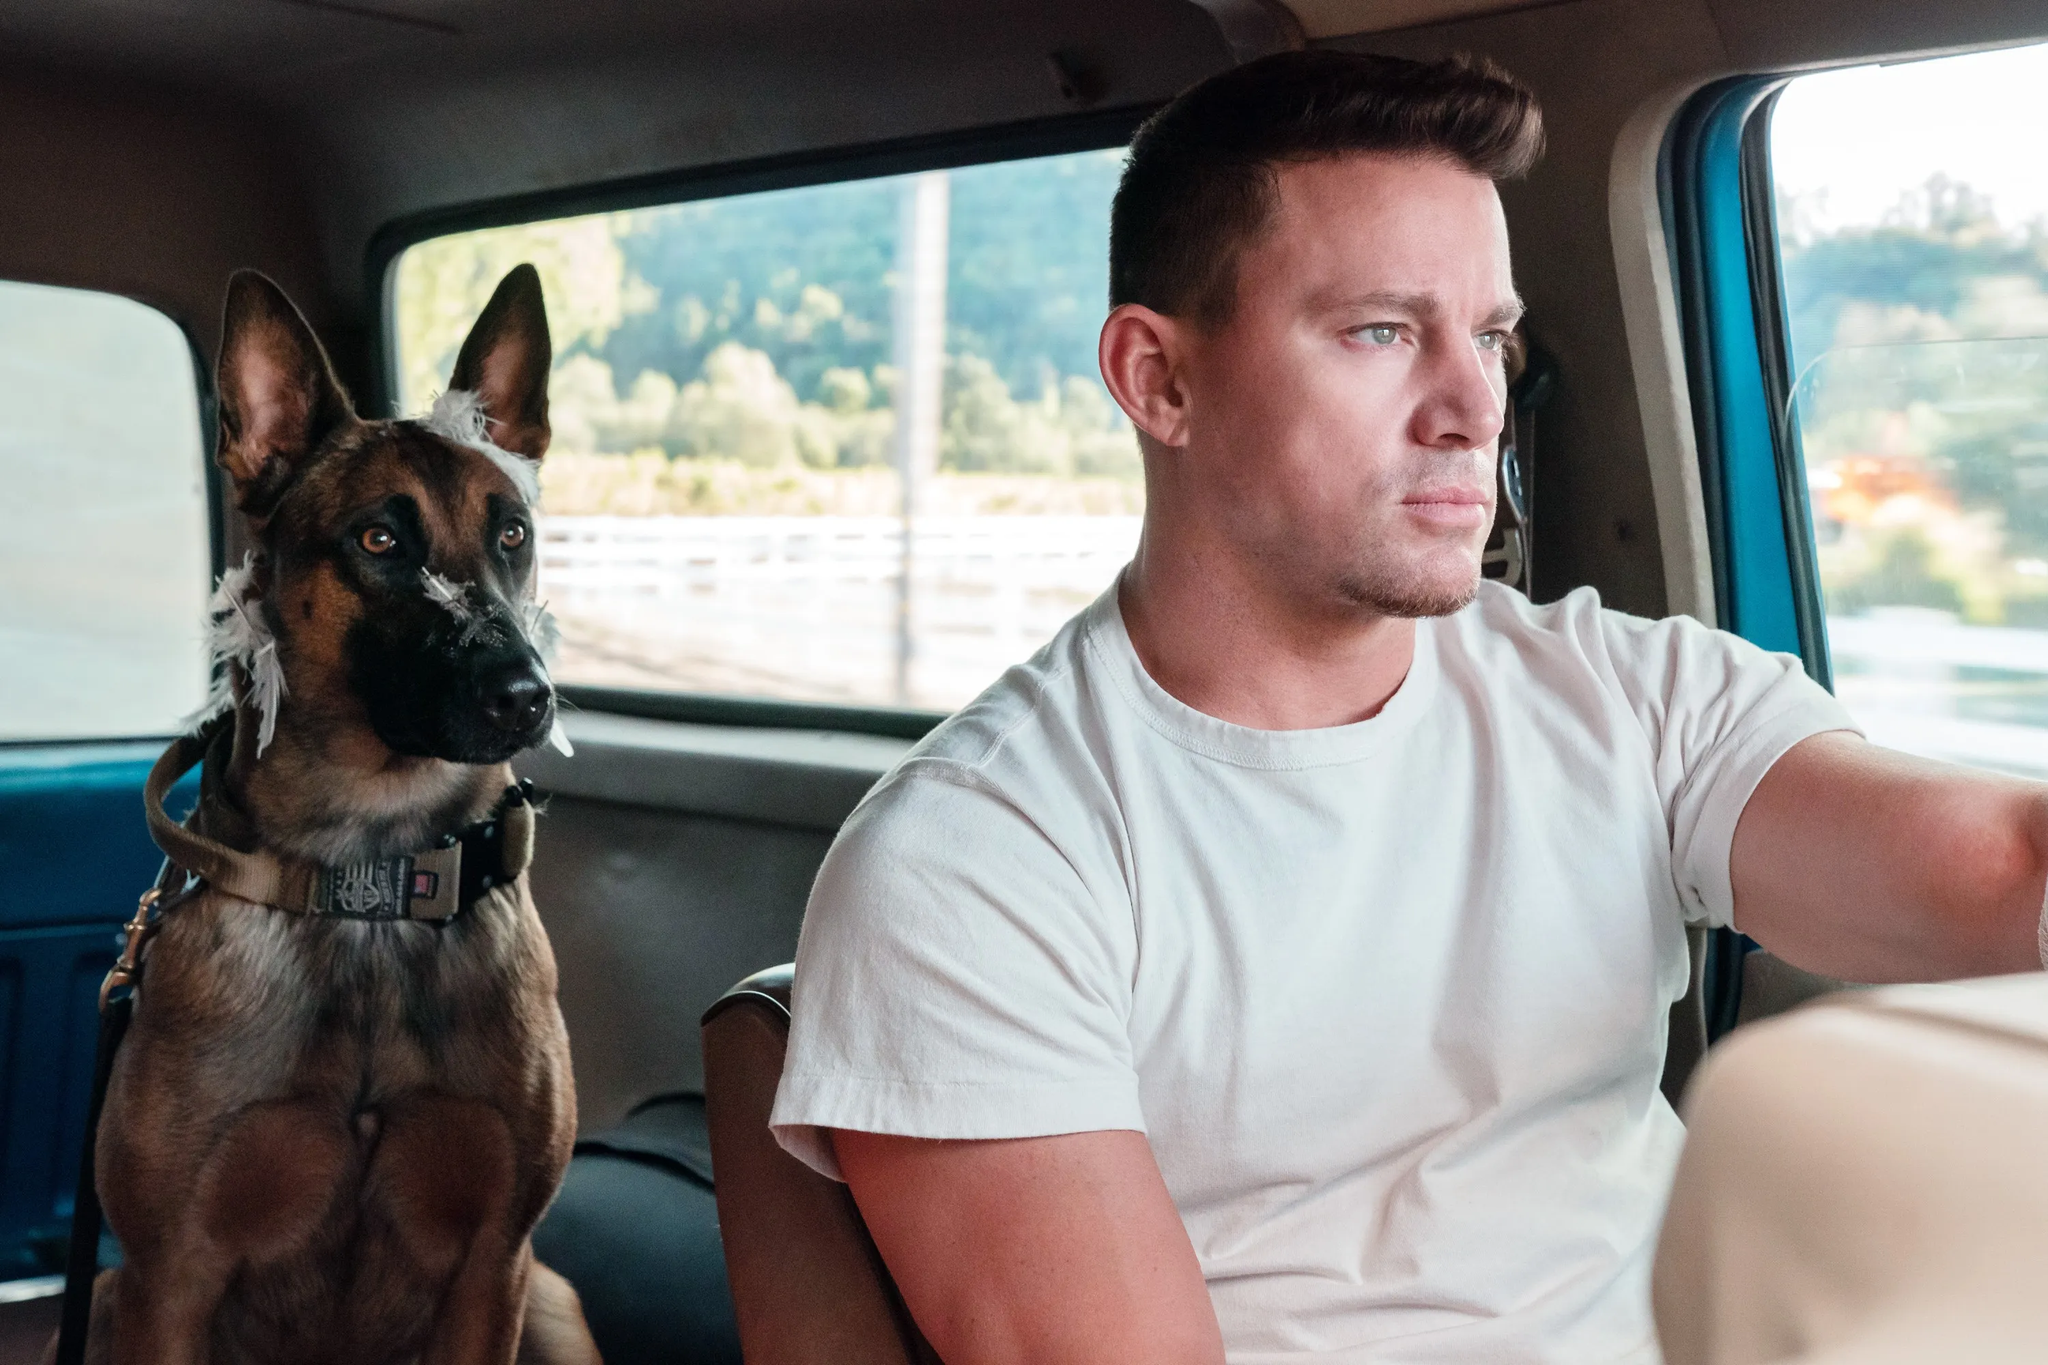If the dog could talk, what story might it share about this journey? If the dog could talk, it might recount the journey with a sense of wonder and excitement. 'Today, my human and I embarked on an adventure far beyond our usual paths. I could feel the thrill in the air as we left home, my nose twitching at the myriad of new scents. The wind whistled through the car window, and I watched as the scenery changed from tall buildings to open fields. My human seemed calm, focused on the road, yet I knew he was as excited as I was for the unknown awaiting us. A sense of companionship filled the car, a silent understanding that, no matter where we go, as long as we are together, it will always be an adventure worth remembering.' 